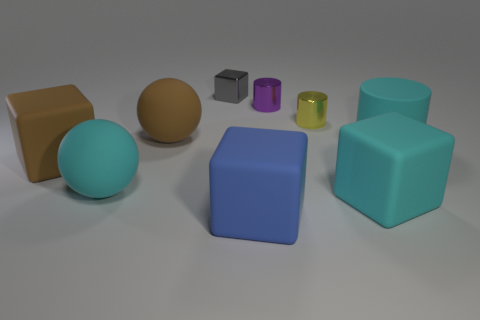Are there any cyan matte spheres?
Offer a very short reply. Yes. There is a tiny yellow cylinder that is to the right of the big block to the left of the large object that is behind the large cyan matte cylinder; what is its material?
Offer a very short reply. Metal. There is a tiny gray shiny object; is it the same shape as the cyan matte thing left of the small gray shiny thing?
Provide a succinct answer. No. How many large cyan things have the same shape as the blue thing?
Make the answer very short. 1. What is the shape of the gray thing?
Offer a terse response. Cube. What is the size of the cube that is right of the small yellow metallic cylinder that is behind the large cyan ball?
Your response must be concise. Large. What number of things are large red things or big spheres?
Your response must be concise. 2. Do the small gray thing and the yellow metal object have the same shape?
Offer a terse response. No. Is there a small object that has the same material as the blue block?
Make the answer very short. No. Are there any small gray metal cubes that are in front of the tiny thing behind the tiny purple cylinder?
Your response must be concise. No. 